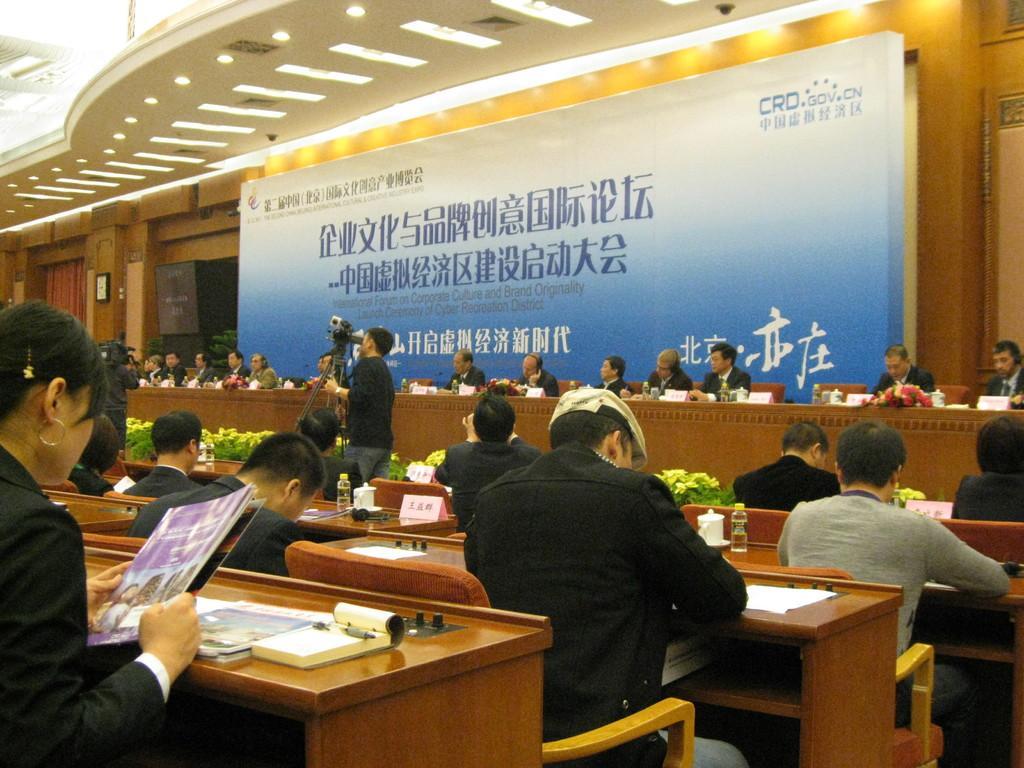How would you summarize this image in a sentence or two? In this image we can see this people are sitting on the chairs near the table. There is a banner in the background. 